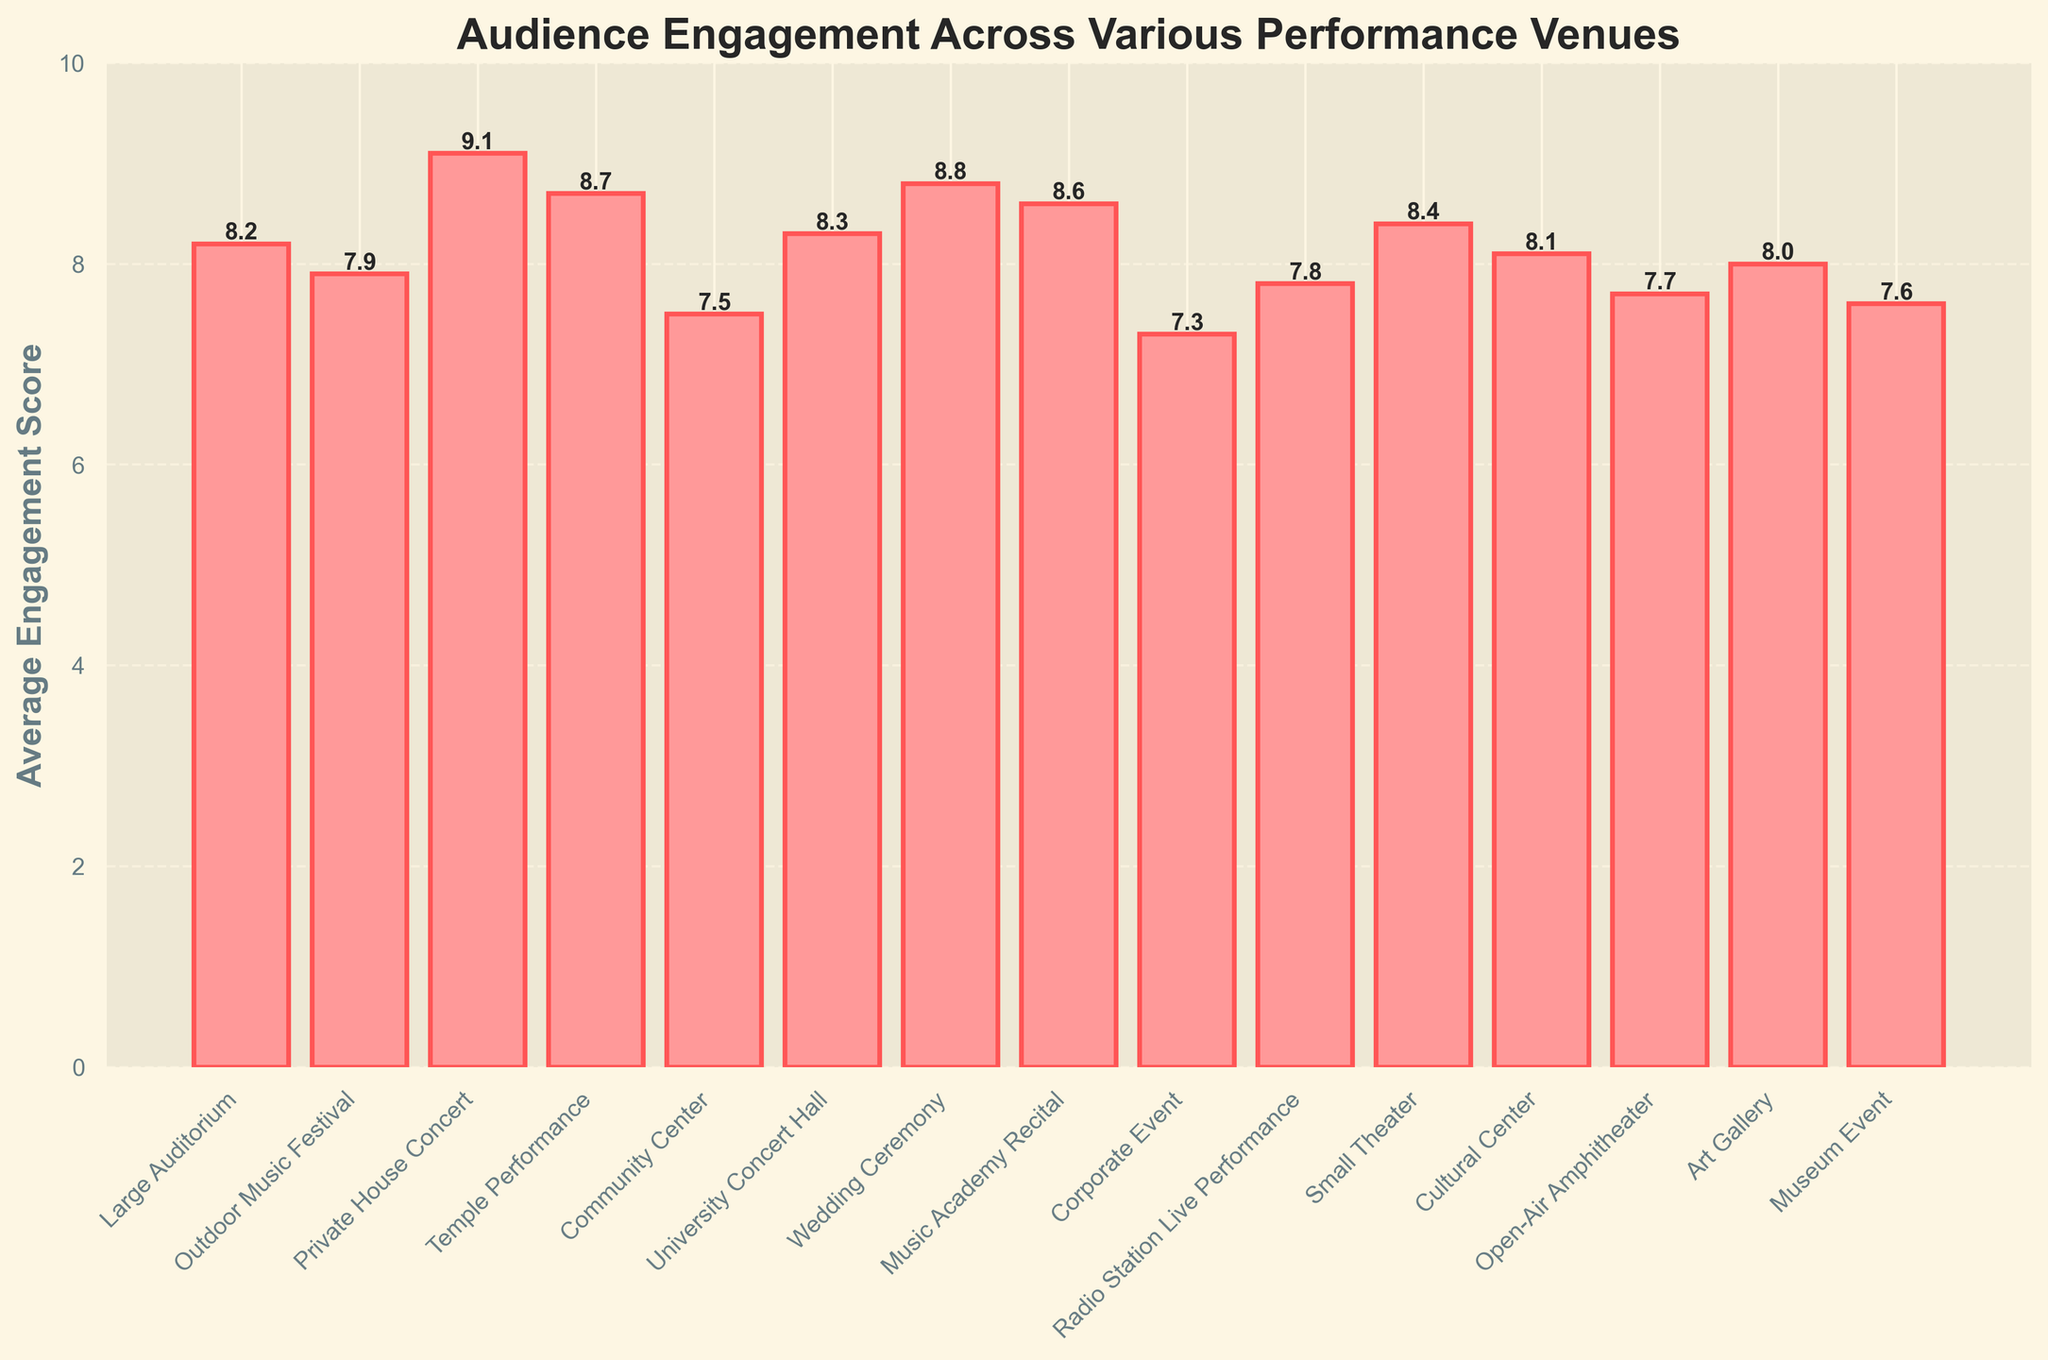Which venue has the highest engagement score? To determine the venue with the highest engagement score, we look at the bar with the highest value. The Private House Concert has the tallest bar with a score of 9.1.
Answer: Private House Concert Which venue has the lowest engagement score? To find the venue with the lowest engagement score, look for the shortest bar in the chart. The Corporate Event has the shortest bar with a score of 7.3.
Answer: Corporate Event How much higher is the engagement score at a Wedding Ceremony compared to a Corporate Event? The Wedding Ceremony has an engagement score of 8.8, and the Corporate Event has a score of 7.3. Subtracting these gives 8.8 - 7.3 = 1.5.
Answer: 1.5 What's the average engagement score for performances at the Temple and University Concert Hall? To calculate the average, first sum the engagement scores of the Temple Performance (8.7) and the University Concert Hall (8.3), which gives 8.7 + 8.3 = 17. Then divide by 2, resulting in 8.5.
Answer: 8.5 How many venues have an engagement score greater than 8.0? Count the bars with scores exceeding 8.0. They are Large Auditorium, Private House Concert, Temple Performance, University Concert Hall, Wedding Ceremony, Music Academy Recital, and Small Theater. There are 7 such venues.
Answer: 7 Which venue types have an engagement score between 7 and 8? Identify the bars with scores between 7 and 8. The relevant venues are Outdoor Music Festival (7.9), Community Center (7.5), Corporate Event (7.3), Radio Station Live Performance (7.8), Open-Air Amphitheater (7.7), and Museum Event (7.6).
Answer: 6 venues Are there more venues with engagement scores above or below 8? Compare the count of venues with scores above 8 to those below 8. There are 8 venues with scores above 8 and 7 venues with scores below 8. Therefore, more venues have scores above 8.
Answer: Above What's the difference in engagement scores between a Small Theater and a Cultural Center? The Small Theater's engagement score is 8.4, and the Cultural Center's score is 8.1. Subtracting the two gives 8.4 - 8.1 = 0.3.
Answer: 0.3 If you were to combine the engagement scores of Large Auditorium, Small Theater, and Art Gallery, what would the total be? Sum the engagement scores of the Large Auditorium (8.2), Small Theater (8.4), and Art Gallery (8.0): 8.2 + 8.4 + 8.0 = 24.6.
Answer: 24.6 